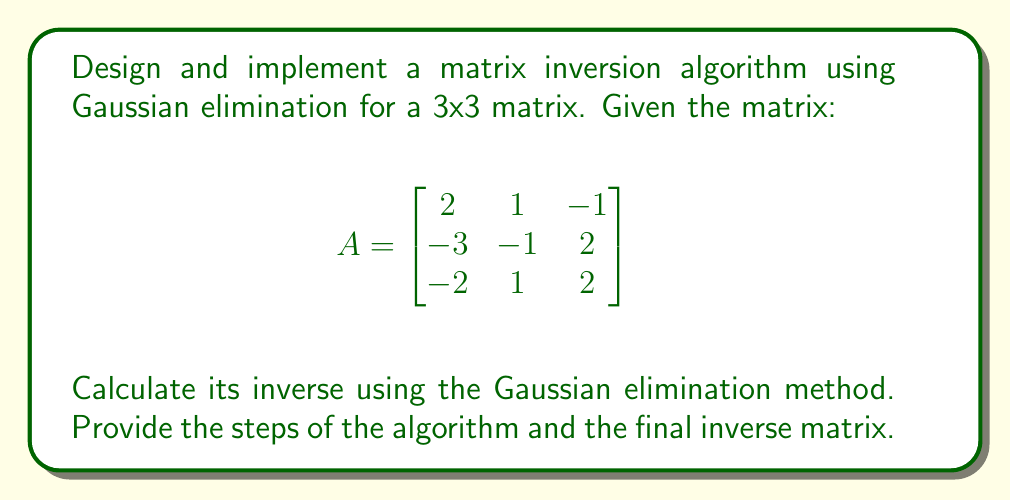Give your solution to this math problem. To invert the matrix using Gaussian elimination, we'll follow these steps:

1. Create an augmented matrix $[A|I]$ where $I$ is the 3x3 identity matrix:

$$[A|I] = \begin{bmatrix}
2 & 1 & -1 & 1 & 0 & 0 \\
-3 & -1 & 2 & 0 & 1 & 0 \\
-2 & 1 & 2 & 0 & 0 & 1
\end{bmatrix}$$

2. Use Gaussian elimination to transform the left side of the augmented matrix into the identity matrix:

a) Multiply row 1 by $\frac{3}{2}$ and add to row 2:
$$\begin{bmatrix}
2 & 1 & -1 & 1 & 0 & 0 \\
0 & \frac{1}{2} & \frac{1}{2} & \frac{3}{2} & 1 & 0 \\
-2 & 1 & 2 & 0 & 0 & 1
\end{bmatrix}$$

b) Add row 1 to row 3:
$$\begin{bmatrix}
2 & 1 & -1 & 1 & 0 & 0 \\
0 & \frac{1}{2} & \frac{1}{2} & \frac{3}{2} & 1 & 0 \\
0 & 2 & 1 & 1 & 0 & 1
\end{bmatrix}$$

c) Multiply row 2 by 2 and subtract from row 3:
$$\begin{bmatrix}
2 & 1 & -1 & 1 & 0 & 0 \\
0 & \frac{1}{2} & \frac{1}{2} & \frac{3}{2} & 1 & 0 \\
0 & 1 & 0 & -2 & -2 & 1
\end{bmatrix}$$

d) Subtract 2 times row 2 from row 1:
$$\begin{bmatrix}
2 & 0 & -2 & -2 & -2 & 0 \\
0 & \frac{1}{2} & \frac{1}{2} & \frac{3}{2} & 1 & 0 \\
0 & 1 & 0 & -2 & -2 & 1
\end{bmatrix}$$

e) Subtract 2 times row 3 from row 1:
$$\begin{bmatrix}
2 & -2 & -2 & 2 & 2 & -2 \\
0 & \frac{1}{2} & \frac{1}{2} & \frac{3}{2} & 1 & 0 \\
0 & 1 & 0 & -2 & -2 & 1
\end{bmatrix}$$

f) Subtract 2 times row 2 from row 3:
$$\begin{bmatrix}
2 & -2 & -2 & 2 & 2 & -2 \\
0 & \frac{1}{2} & \frac{1}{2} & \frac{3}{2} & 1 & 0 \\
0 & 0 & -1 & -5 & -4 & 1
\end{bmatrix}$$

3. Divide each row by its leading coefficient:
$$\begin{bmatrix}
1 & -1 & -1 & 1 & 1 & -1 \\
0 & 1 & 1 & 3 & 2 & 0 \\
0 & 0 & 1 & 5 & 4 & -1
\end{bmatrix}$$

4. Use back-substitution to eliminate the upper triangular elements:

a) Add row 3 to row 2:
$$\begin{bmatrix}
1 & -1 & -1 & 1 & 1 & -1 \\
0 & 1 & 0 & -2 & -2 & 1 \\
0 & 0 & 1 & 5 & 4 & -1
\end{bmatrix}$$

b) Add row 3 to row 1 and add row 2 to row 1:
$$\begin{bmatrix}
1 & 0 & 0 & 4 & 3 & -1 \\
0 & 1 & 0 & -2 & -2 & 1 \\
0 & 0 & 1 & 5 & 4 & -1
\end{bmatrix}$$

5. The right side of the augmented matrix is now $A^{-1}$:

$$A^{-1} = \begin{bmatrix}
4 & 3 & -1 \\
-2 & -2 & 1 \\
5 & 4 & -1
\end{bmatrix}$$
Answer: $$A^{-1} = \begin{bmatrix}
4 & 3 & -1 \\
-2 & -2 & 1 \\
5 & 4 & -1
\end{bmatrix}$$ 